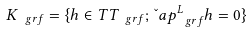Convert formula to latex. <formula><loc_0><loc_0><loc_500><loc_500>K _ { \ g r f } = \{ h \in T T _ { \ g r f } ; \, \L a p ^ { L } _ { \ g r f } h = 0 \}</formula> 